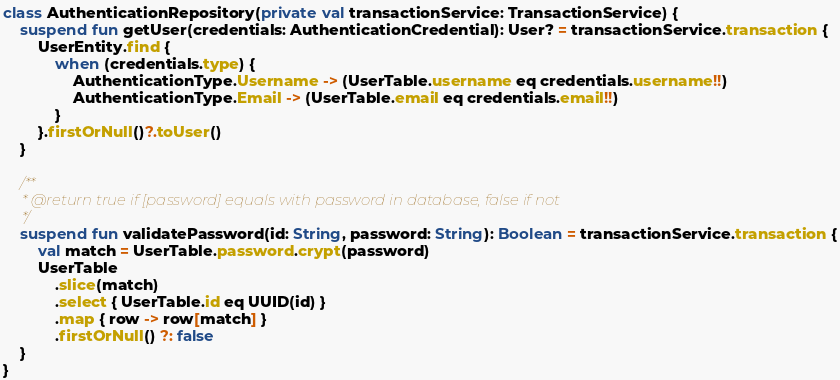<code> <loc_0><loc_0><loc_500><loc_500><_Kotlin_>class AuthenticationRepository(private val transactionService: TransactionService) {
    suspend fun getUser(credentials: AuthenticationCredential): User? = transactionService.transaction {
        UserEntity.find {
            when (credentials.type) {
                AuthenticationType.Username -> (UserTable.username eq credentials.username!!)
                AuthenticationType.Email -> (UserTable.email eq credentials.email!!)
            }
        }.firstOrNull()?.toUser()
    }

    /**
     * @return true if [password] equals with password in database, false if not
     */
    suspend fun validatePassword(id: String, password: String): Boolean = transactionService.transaction {
        val match = UserTable.password.crypt(password)
        UserTable
            .slice(match)
            .select { UserTable.id eq UUID(id) }
            .map { row -> row[match] }
            .firstOrNull() ?: false
    }
}
</code> 